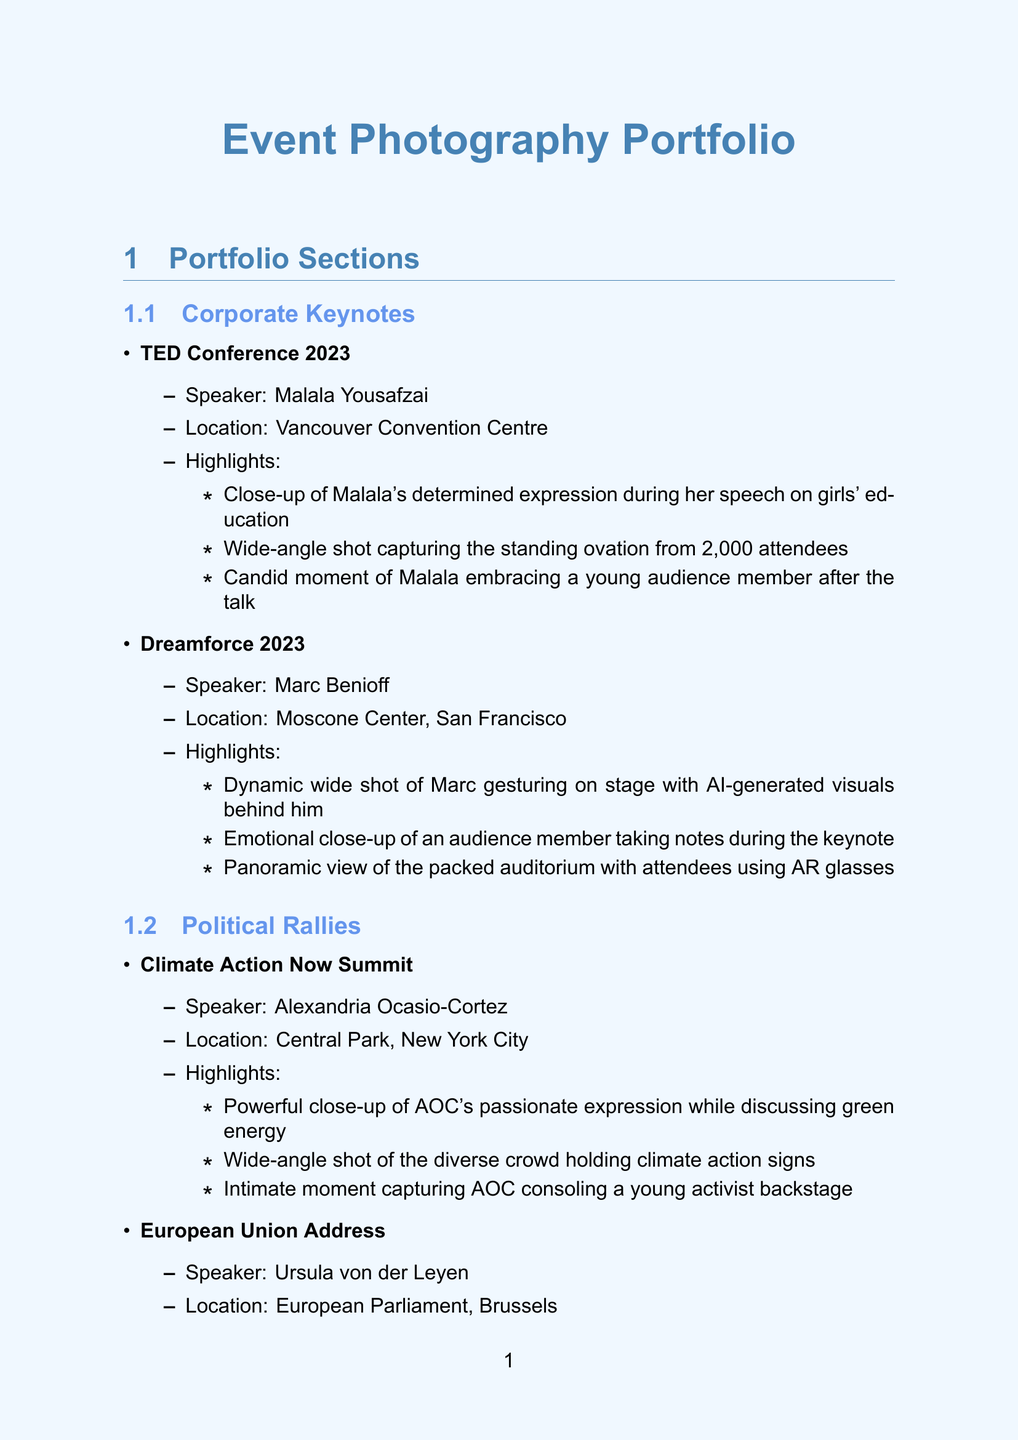What is the event name for Malala Yousafzai's speech? The event name is specifically mentioned under Corporate Keynotes, which is the TED Conference 2023.
Answer: TED Conference 2023 Who was the speaker at the Climate Action Now Summit? The speaker is detailed in the Political Rallies section, clearly identified as Alexandria Ocasio-Cortez.
Answer: Alexandria Ocasio-Cortez How many attendees were present at the TED Conference 2023? The number of attendees is provided in the highlights for the event, indicating 2,000 attendees were present.
Answer: 2,000 What equipment is listed as a photography accessory? One of the accessories is named in the photography equipment section, specifying the items used by the photographer.
Answer: Profoto B10 Plus flash kit What type of shot captures the diverse crowd at the Climate Action Now Summit? The document describes specific highlights that indicate the type of shots taken, showing that it is a wide-angle shot.
Answer: Wide-angle shot Which photography software is used for post-processing? The workflow section outlines the software used exclusively for this purpose, which is Adobe Lightroom Classic.
Answer: Adobe Lightroom Classic What emotional moment occurred during Oprah Winfrey's speech? The highlights section of the academic lectures recounts a specific poignant interaction that occurred, emphasizing an emotional encounter.
Answer: Oprah hugging a first-generation college graduate Which section features Marc Benioff as a speaker? The section that includes Marc Benioff is categorized under Corporate Keynotes, indicating his notable appearance.
Answer: Corporate Keynotes What is one of the lenses used by the photographer? The photography equipment section lists specific lenses, providing options for what the photographer used, including various focal lengths.
Answer: Sony FE 24-70mm f/2.8 GM II 